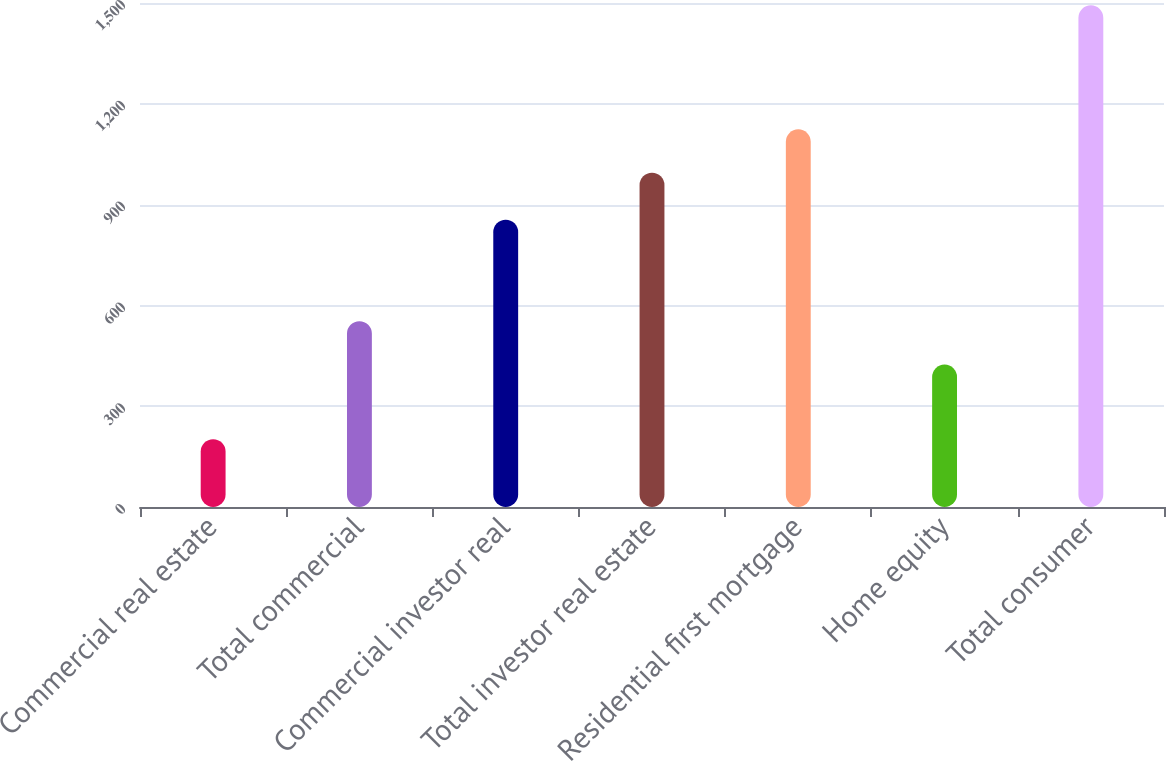<chart> <loc_0><loc_0><loc_500><loc_500><bar_chart><fcel>Commercial real estate<fcel>Total commercial<fcel>Commercial investor real<fcel>Total investor real estate<fcel>Residential first mortgage<fcel>Home equity<fcel>Total consumer<nl><fcel>202<fcel>553.1<fcel>855<fcel>995<fcel>1124.1<fcel>424<fcel>1493<nl></chart> 